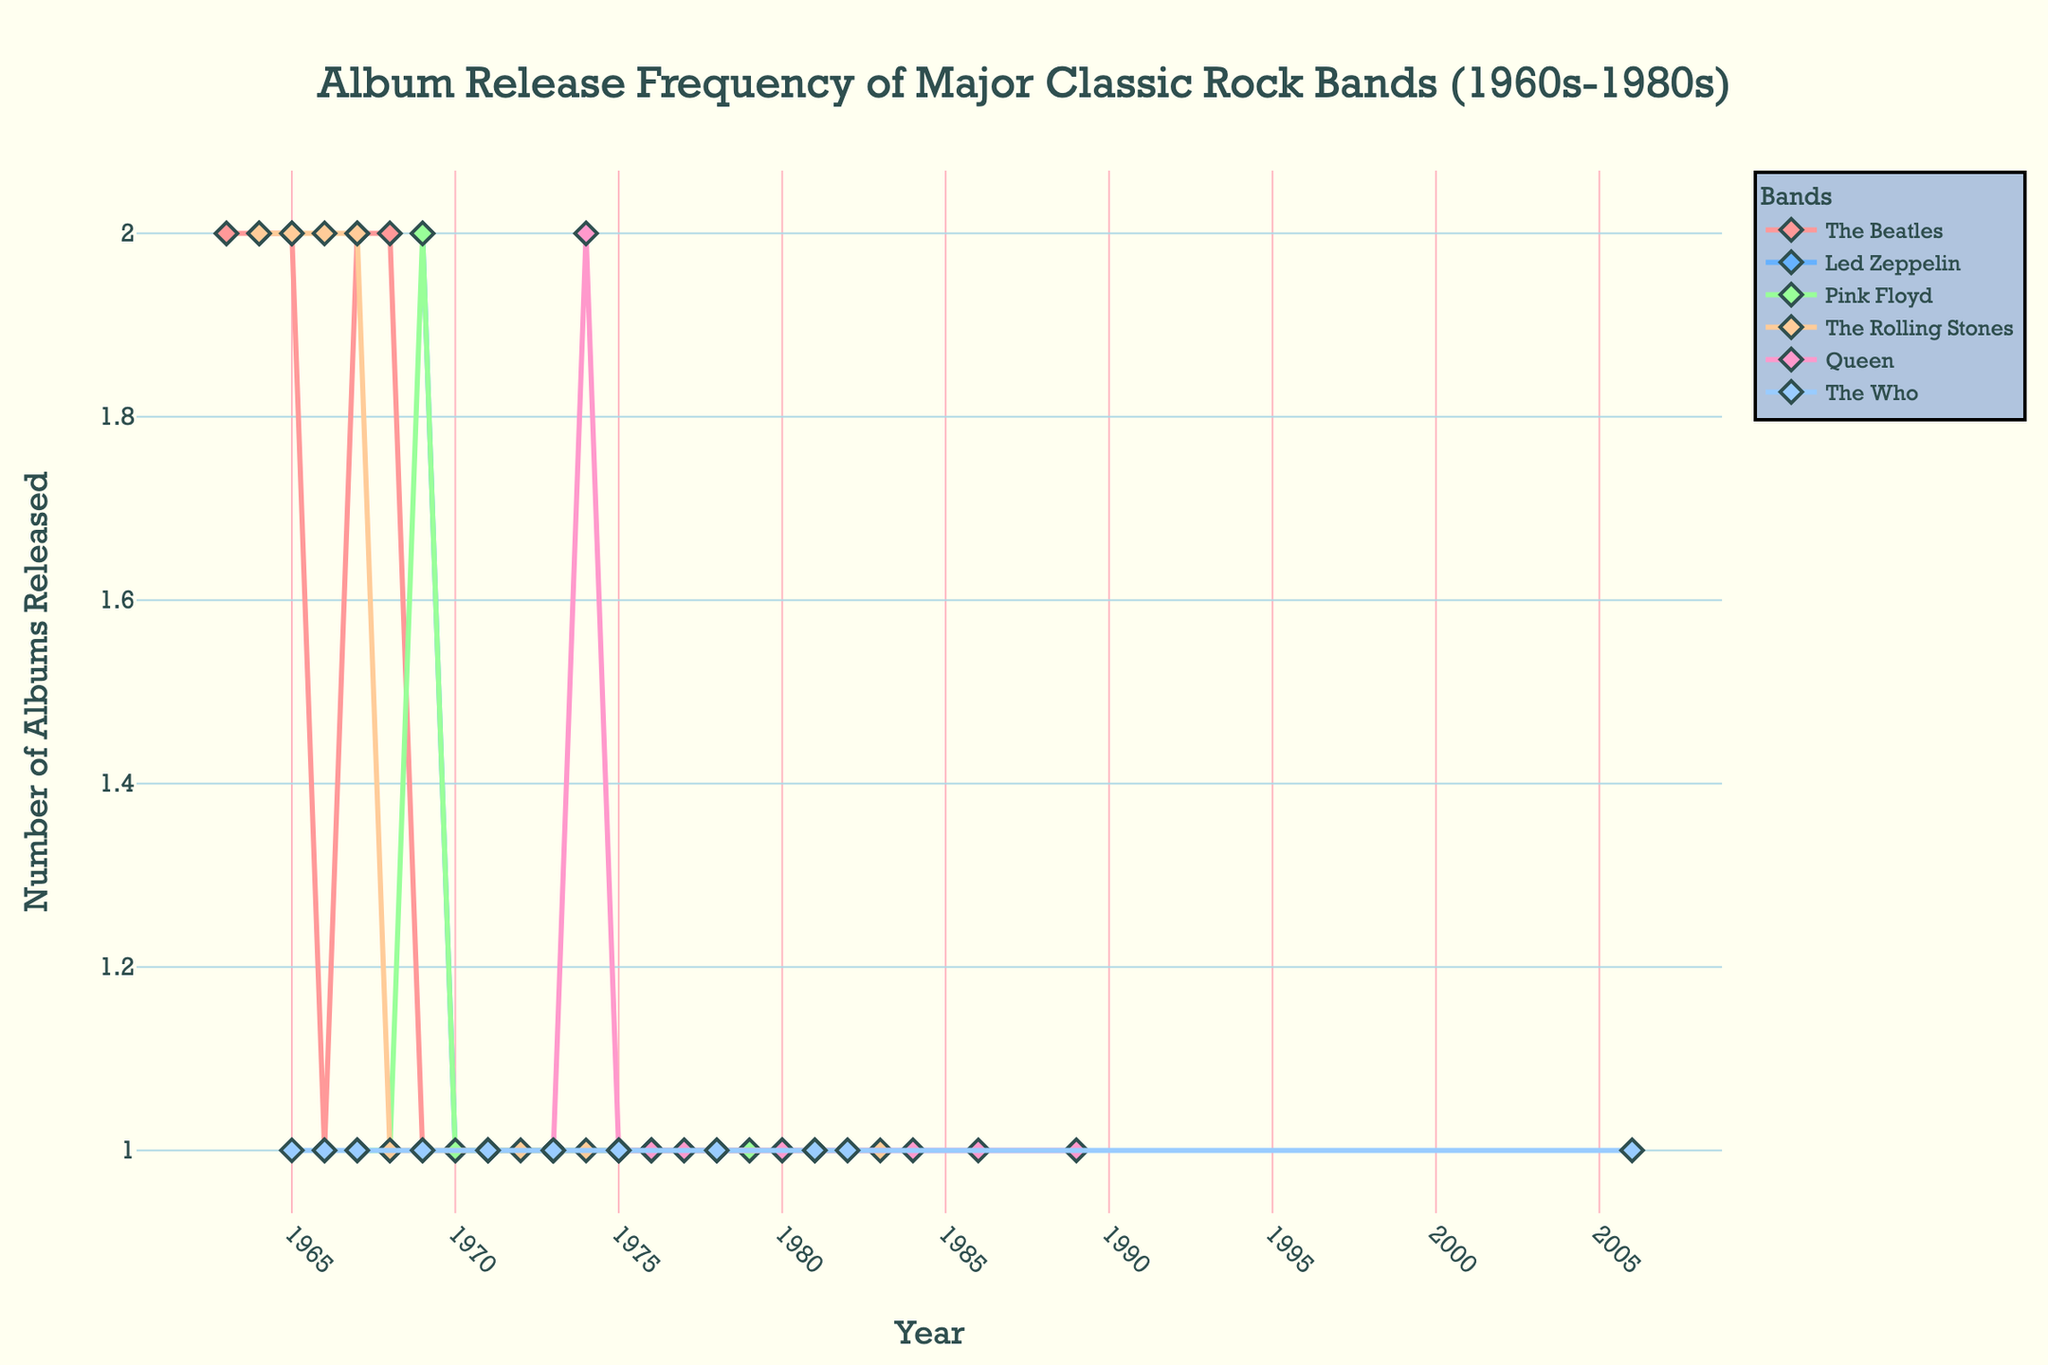What is the title of the plot? The title of the plot is located at the top center of the figure, written in a larger and bold font compared to the rest of the text.
Answer: Album Release Frequency of Major Classic Rock Bands (1960s-1980s) Which bands have series that continue into the 1980s? To determine this, look for traces that extend beyond 1979 into the 1980s. The bands that continue into this period on the x-axis are 'The Rolling Stones', 'Queen', and 'The Who'.
Answer: The Rolling Stones, Queen, The Who How many albums did The Rolling Stones release in 1981? Locate the point on the 'The Rolling Stones' trace that corresponds to 1981 on the x-axis. The y-value at this point represents the number of albums released.
Answer: 1 Which band released the most albums in a single year and how many were released? Scan through all the traces to find the highest peak, which represents the maximum number of albums released by any band in a single year. Both 'The Beatles' and 'Led Zeppelin' released 2 albums in a year.
Answer: The Beatles, Led Zeppelin; 2 Between 1967 and 1969, which band had the most consistent album release pattern? During the period 1967 to 1969, examine the traces for all bands to see which one had a repeated or stable number of releases each year. 'The Rolling Stones' and 'Pink Floyd' released albums each year, but 'The Rolling Stones' consistently released 1 album each year.
Answer: The Rolling Stones What can you say about the release frequency of Pink Floyd from 1970 to 1980? Examine the 'Pink Floyd' trace from 1970 to 1980 on the x-axis and observe the y-values. Pink Floyd released 1 album almost every year during this period, indicating a steady frequency.
Answer: Steady, 1 album almost every year How does the release pattern of Led Zeppelin compare to The Who in the 1970s? Compare the traces for 'Led Zeppelin' and 'The Who' in the 1970s. 'Led Zeppelin' released albums in specific years at a rate of one album approximately every two years, while 'The Who’s release pattern was similar but they released fewer albums overall.
Answer: Led Zeppelin: Every 2 years; The Who: Similar frequency, fewer albums What is the color assigned to Queen in the plot? Each band's trace is represented by a different color. 'Queen' is assigned a specific color which can be observed in the legend or by looking at the trace itself.
Answer: Light Pink Which year saw the highest number of total albums released by all bands combined? Sum the number of albums released by all bands for each year and identify the year with the highest total sum. In 1969, the total is highest with multiple bands releasing several albums.
Answer: 1969 In the 1980s, did The Who release more albums compared to Queen? Compare the number of albums released by 'The Who' and 'Queen' in the 1980s by counting the data points in their respective traces within this period.
Answer: No 